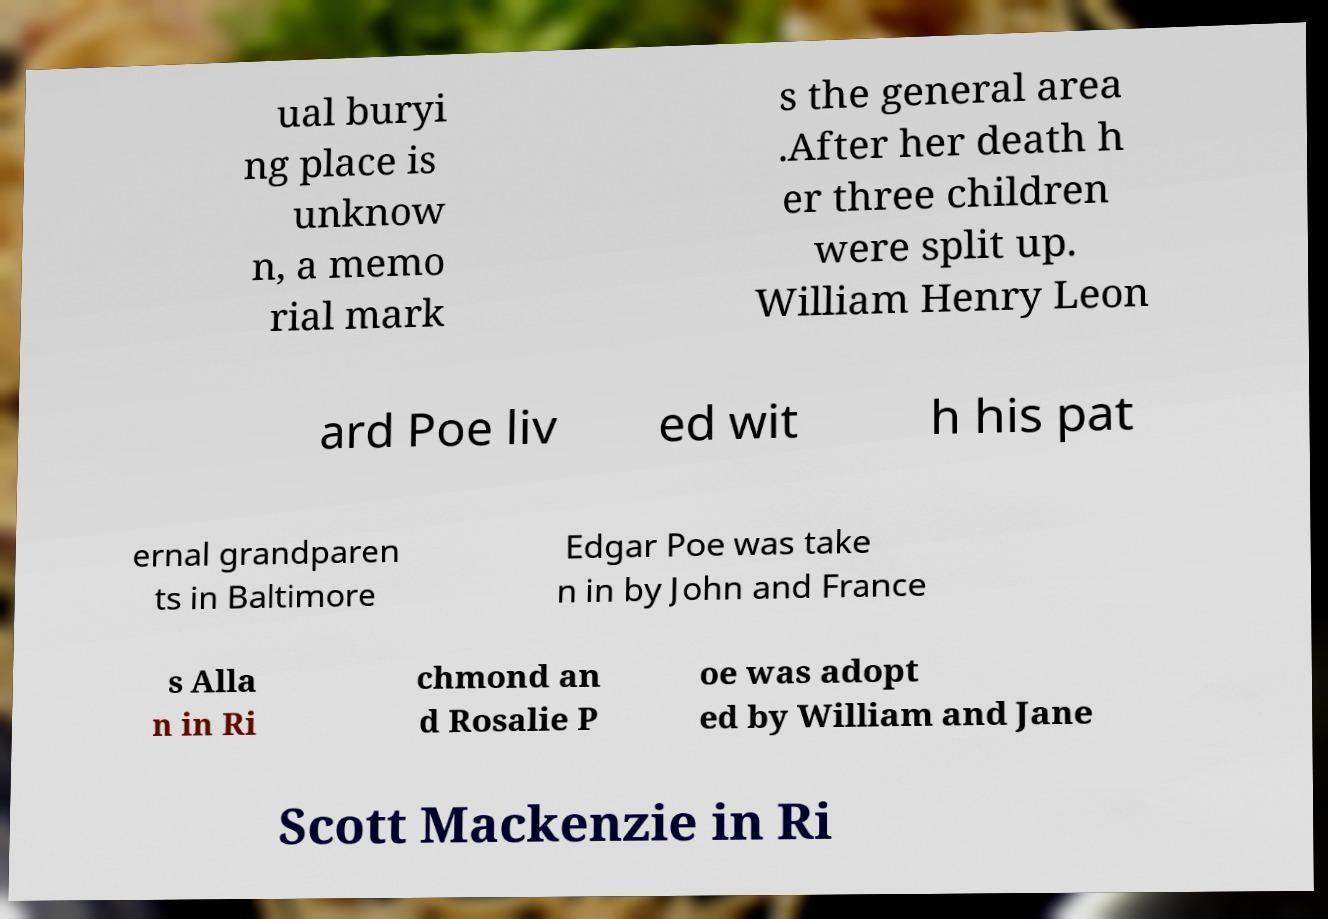For documentation purposes, I need the text within this image transcribed. Could you provide that? ual buryi ng place is unknow n, a memo rial mark s the general area .After her death h er three children were split up. William Henry Leon ard Poe liv ed wit h his pat ernal grandparen ts in Baltimore Edgar Poe was take n in by John and France s Alla n in Ri chmond an d Rosalie P oe was adopt ed by William and Jane Scott Mackenzie in Ri 